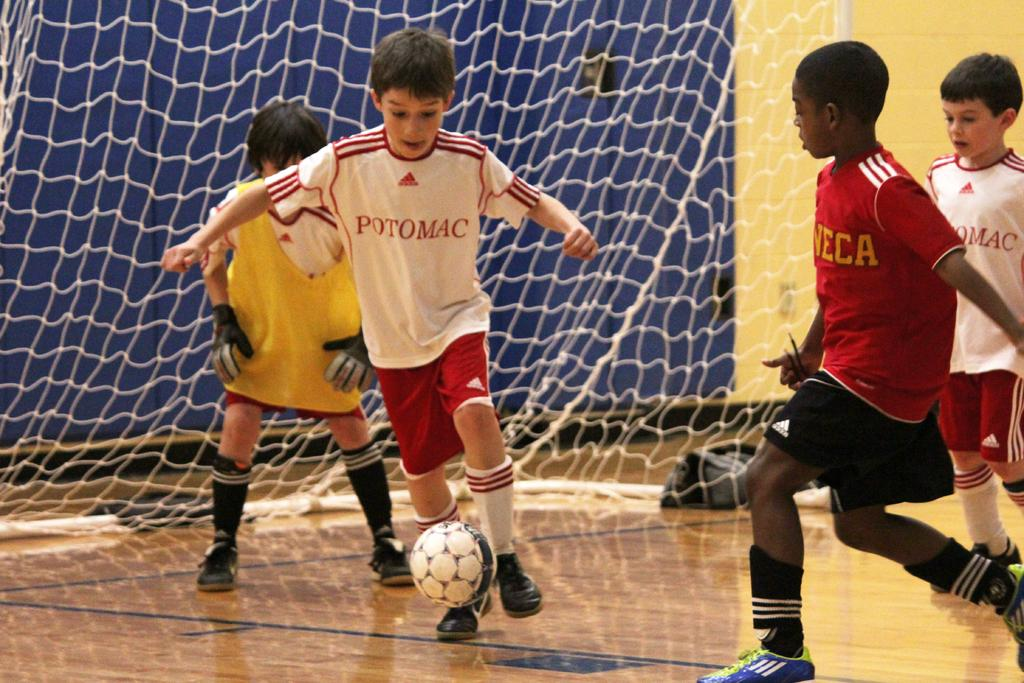How many boys are playing football in the image? There are four boys in the image. What sport are the boys playing? The boys are playing football. What can be seen in the background of the image? There is a football net in the background of the image. What is the limit of passengers allowed on the football field in the image? There is no mention of passengers or a limit in the image, as it features four boys playing football on a field with a football net in the background. 